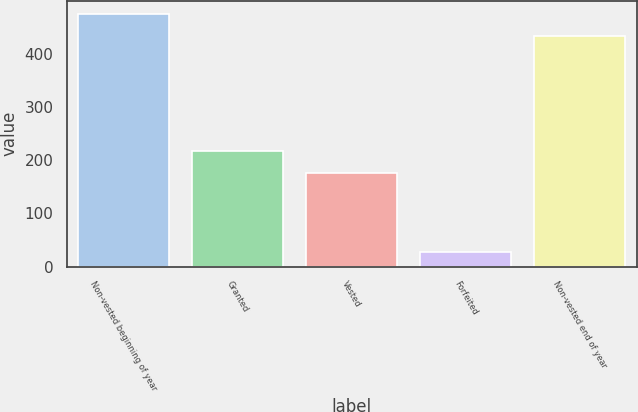Convert chart. <chart><loc_0><loc_0><loc_500><loc_500><bar_chart><fcel>Non-vested beginning of year<fcel>Granted<fcel>Vested<fcel>Forfeited<fcel>Non-vested end of year<nl><fcel>476<fcel>218<fcel>176<fcel>27<fcel>434<nl></chart> 